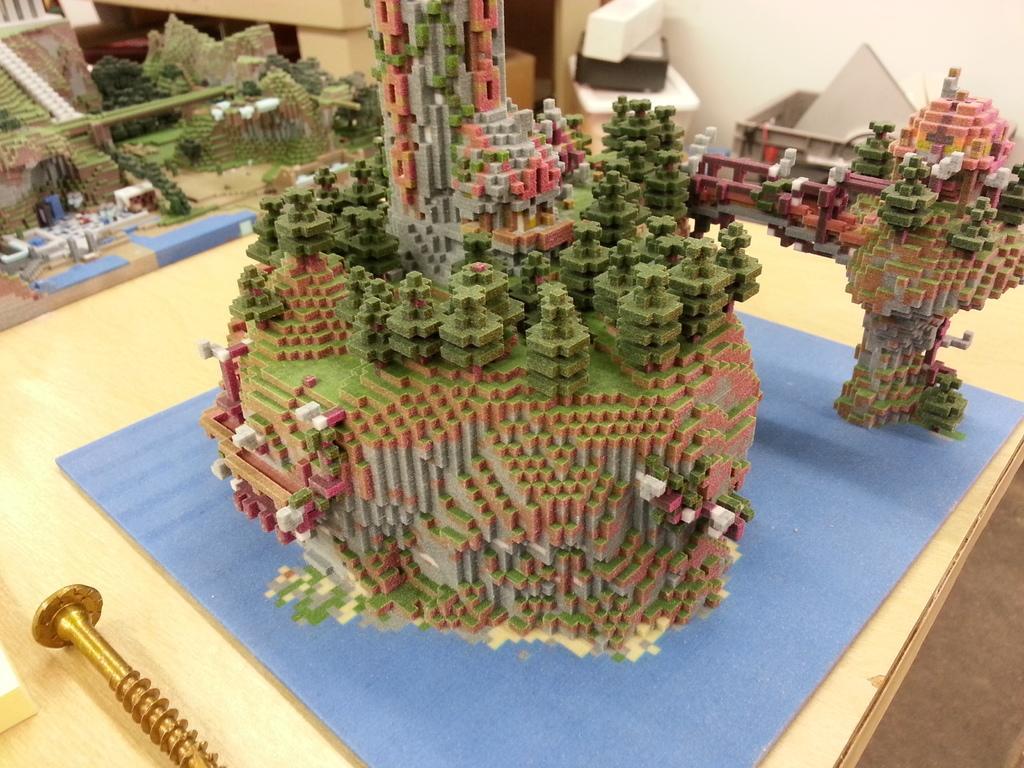Please provide a concise description of this image. In this image I can see a colorful miniatures on the table. On the left bottom of the image I can see a nail. 